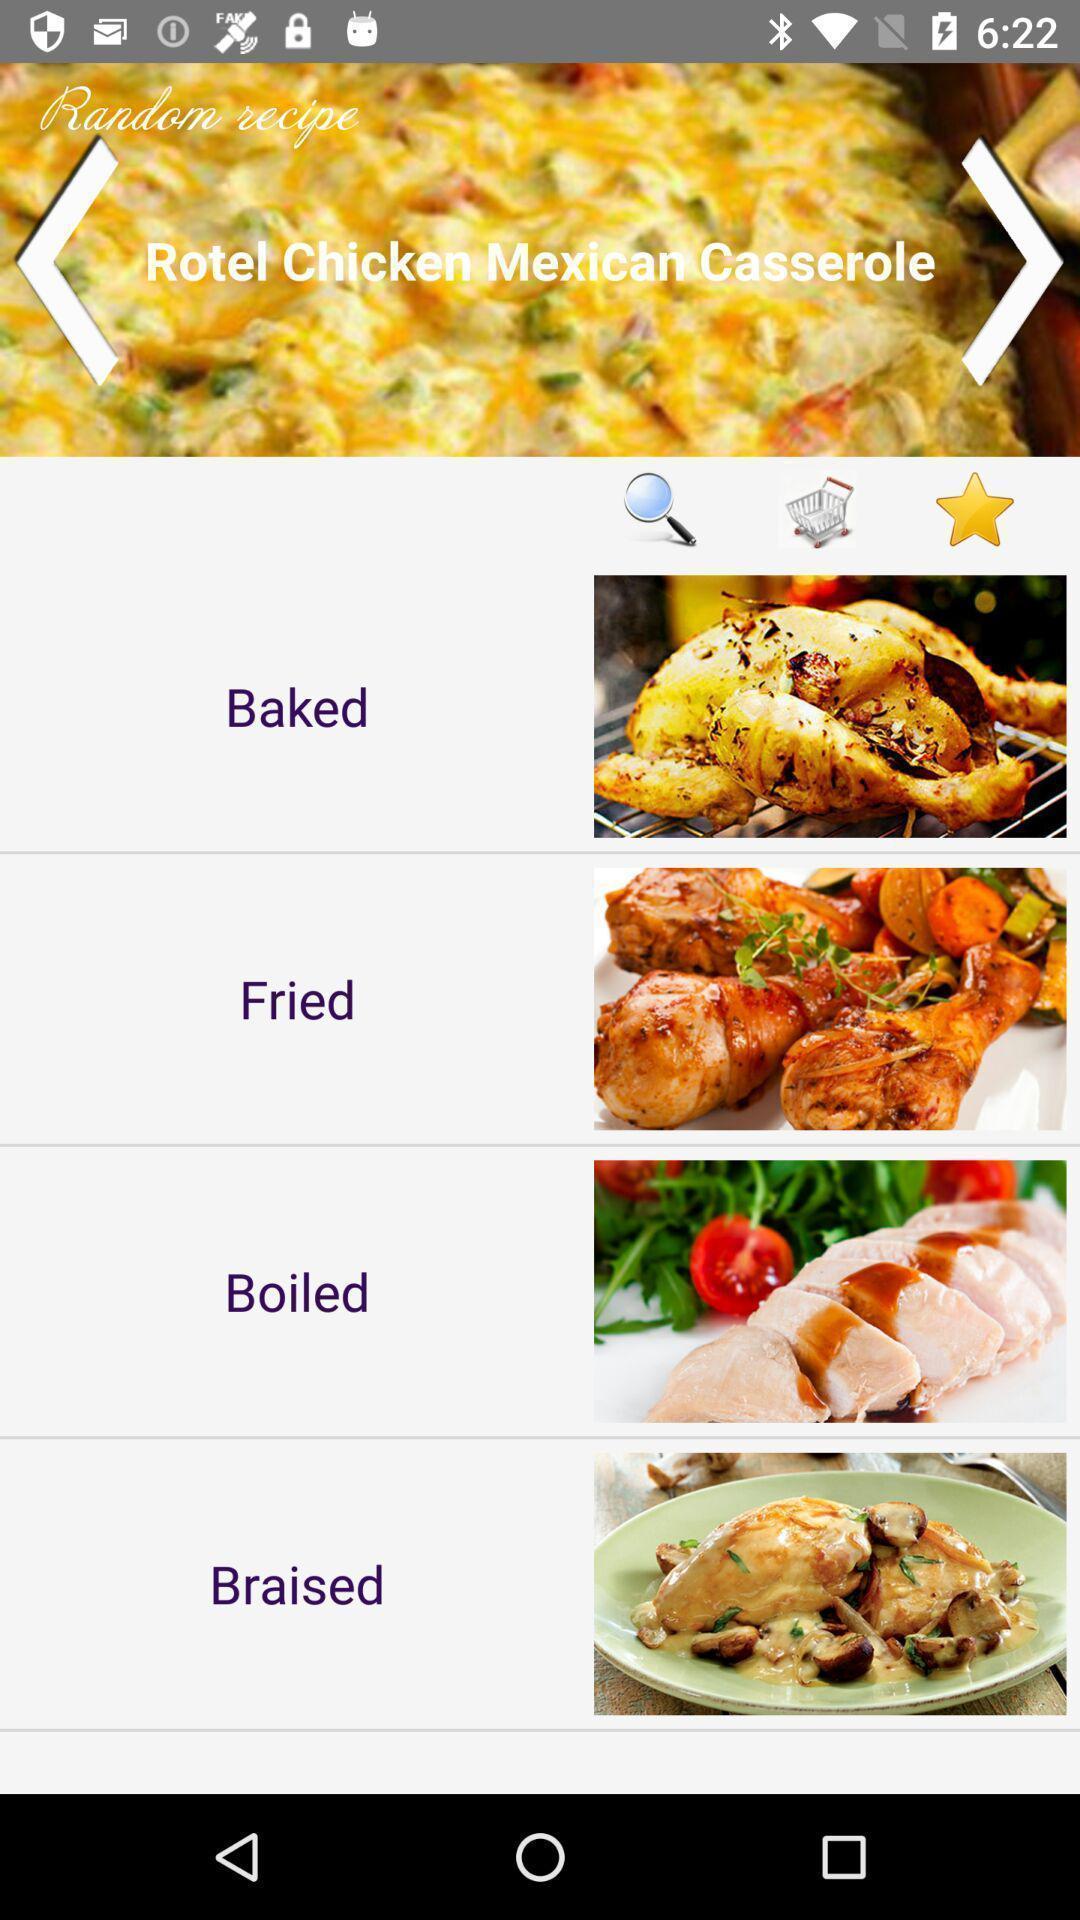Provide a textual representation of this image. Screen displaying multiple category options of a food item. 